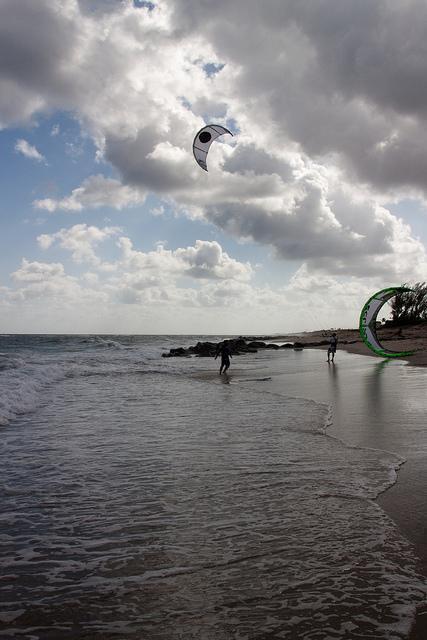How many sheep are in the picture?
Give a very brief answer. 0. 